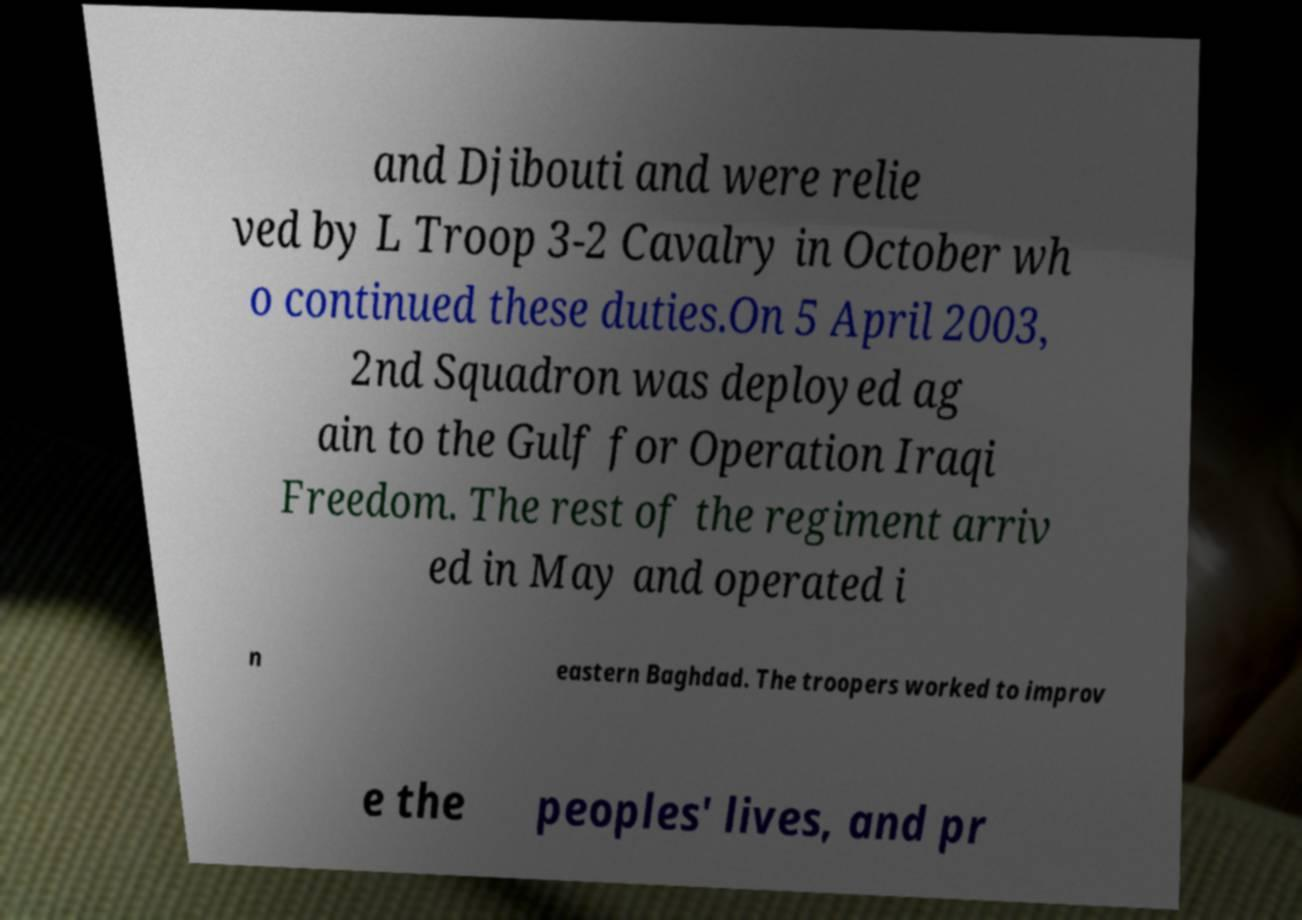Please read and relay the text visible in this image. What does it say? and Djibouti and were relie ved by L Troop 3-2 Cavalry in October wh o continued these duties.On 5 April 2003, 2nd Squadron was deployed ag ain to the Gulf for Operation Iraqi Freedom. The rest of the regiment arriv ed in May and operated i n eastern Baghdad. The troopers worked to improv e the peoples' lives, and pr 